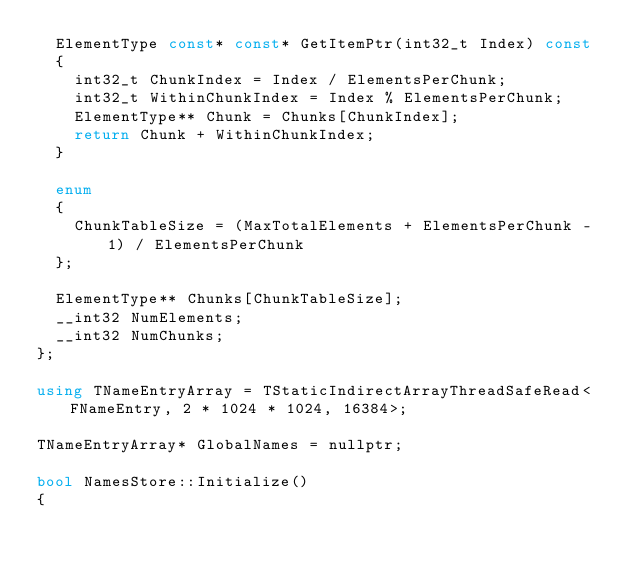<code> <loc_0><loc_0><loc_500><loc_500><_C++_>	ElementType const* const* GetItemPtr(int32_t Index) const
	{
		int32_t ChunkIndex = Index / ElementsPerChunk;
		int32_t WithinChunkIndex = Index % ElementsPerChunk;
		ElementType** Chunk = Chunks[ChunkIndex];
		return Chunk + WithinChunkIndex;
	}

	enum
	{
		ChunkTableSize = (MaxTotalElements + ElementsPerChunk - 1) / ElementsPerChunk
	};

	ElementType** Chunks[ChunkTableSize];
	__int32 NumElements;
	__int32 NumChunks;
};

using TNameEntryArray = TStaticIndirectArrayThreadSafeRead<FNameEntry, 2 * 1024 * 1024, 16384>;

TNameEntryArray* GlobalNames = nullptr;

bool NamesStore::Initialize()
{</code> 